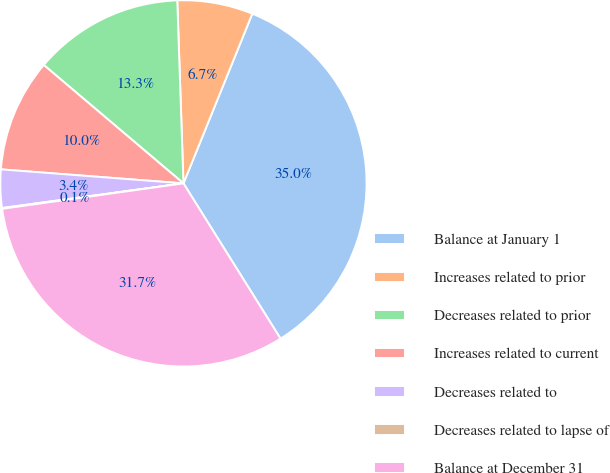<chart> <loc_0><loc_0><loc_500><loc_500><pie_chart><fcel>Balance at January 1<fcel>Increases related to prior<fcel>Decreases related to prior<fcel>Increases related to current<fcel>Decreases related to<fcel>Decreases related to lapse of<fcel>Balance at December 31<nl><fcel>34.97%<fcel>6.67%<fcel>13.27%<fcel>9.97%<fcel>3.37%<fcel>0.07%<fcel>31.67%<nl></chart> 